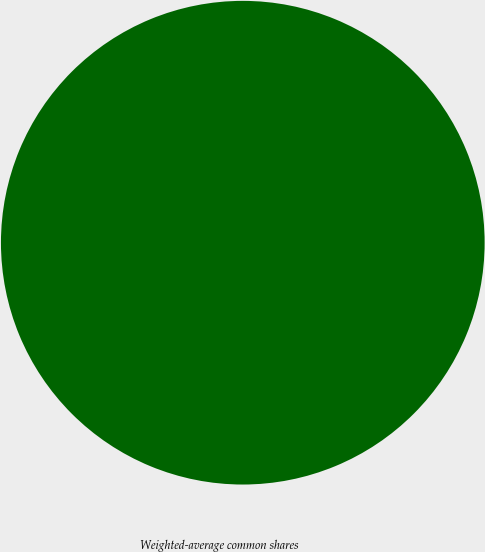Convert chart. <chart><loc_0><loc_0><loc_500><loc_500><pie_chart><fcel>Weighted-average common shares<nl><fcel>100.0%<nl></chart> 